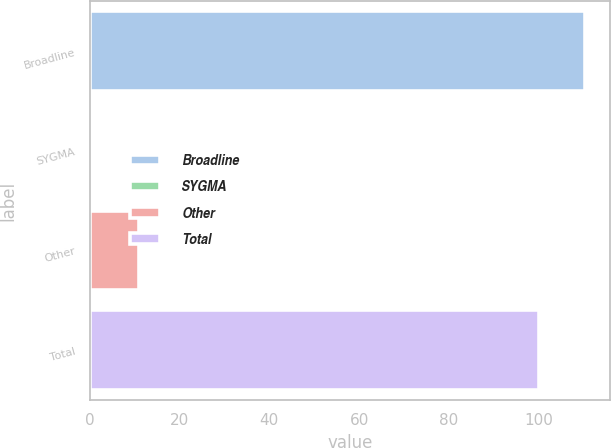Convert chart. <chart><loc_0><loc_0><loc_500><loc_500><bar_chart><fcel>Broadline<fcel>SYGMA<fcel>Other<fcel>Total<nl><fcel>110.34<fcel>0.6<fcel>10.94<fcel>100<nl></chart> 